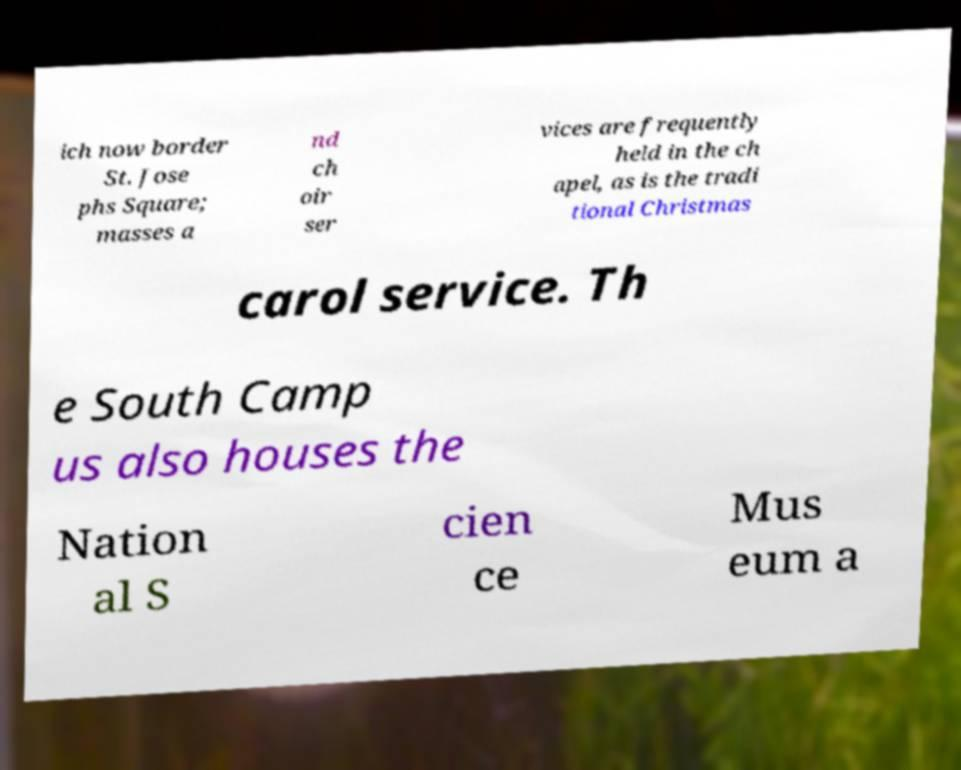For documentation purposes, I need the text within this image transcribed. Could you provide that? ich now border St. Jose phs Square; masses a nd ch oir ser vices are frequently held in the ch apel, as is the tradi tional Christmas carol service. Th e South Camp us also houses the Nation al S cien ce Mus eum a 